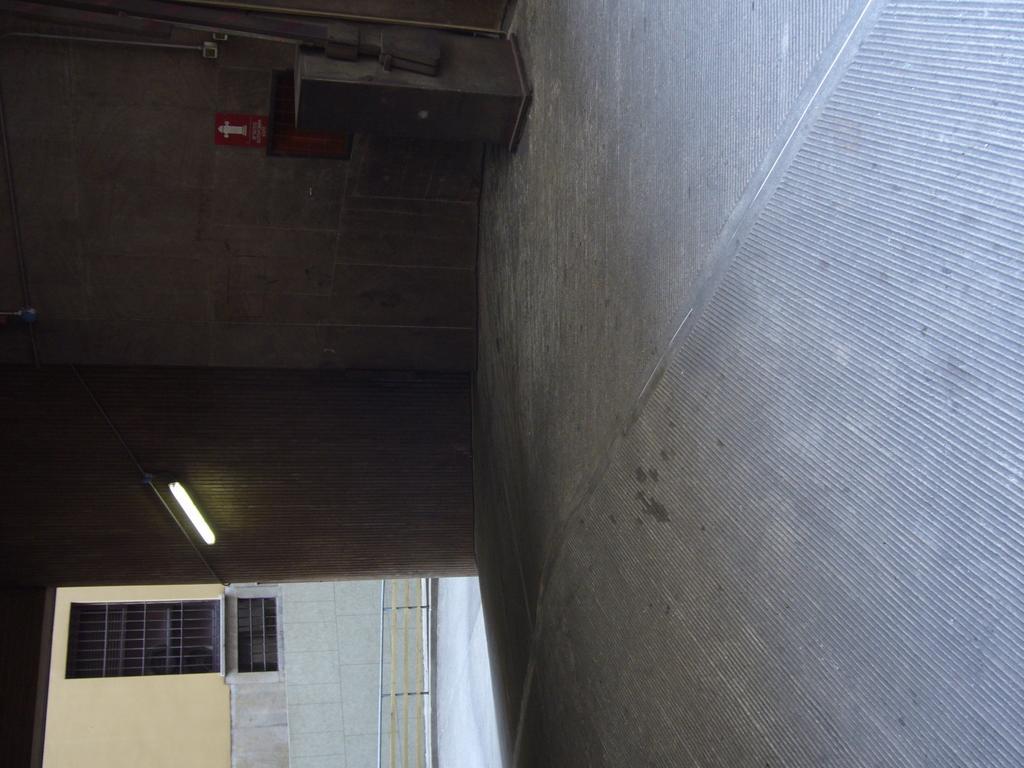Please provide a concise description of this image. Right side of the image floor is there. Bottom of the image one wall is present. Top of the image one table is present and pipes are attached to the wall. On wall one light is attached. 